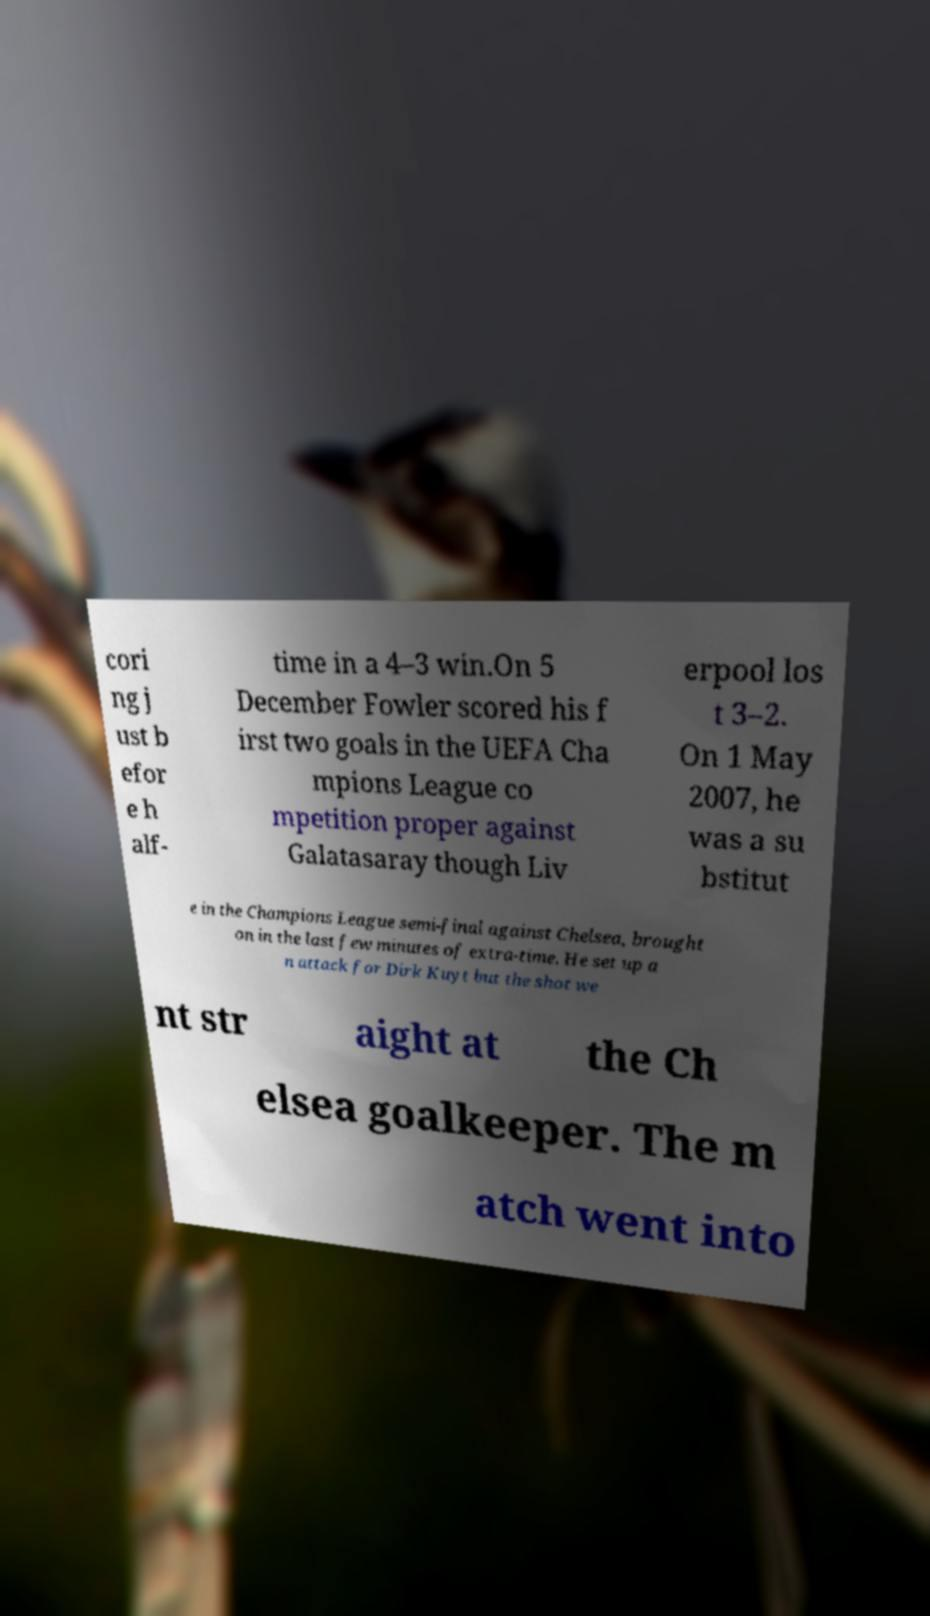Please read and relay the text visible in this image. What does it say? cori ng j ust b efor e h alf- time in a 4–3 win.On 5 December Fowler scored his f irst two goals in the UEFA Cha mpions League co mpetition proper against Galatasaray though Liv erpool los t 3–2. On 1 May 2007, he was a su bstitut e in the Champions League semi-final against Chelsea, brought on in the last few minutes of extra-time. He set up a n attack for Dirk Kuyt but the shot we nt str aight at the Ch elsea goalkeeper. The m atch went into 